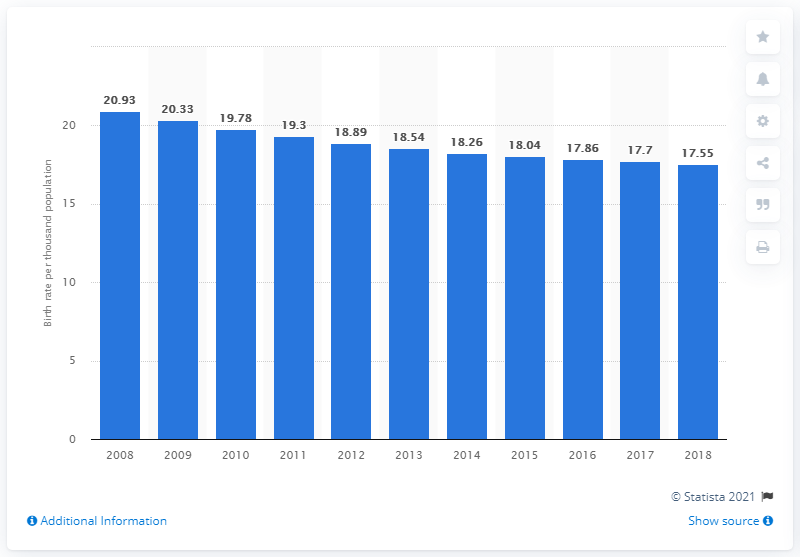Mention a couple of crucial points in this snapshot. In 2018, the crude birth rate in Burma was 17.55. 